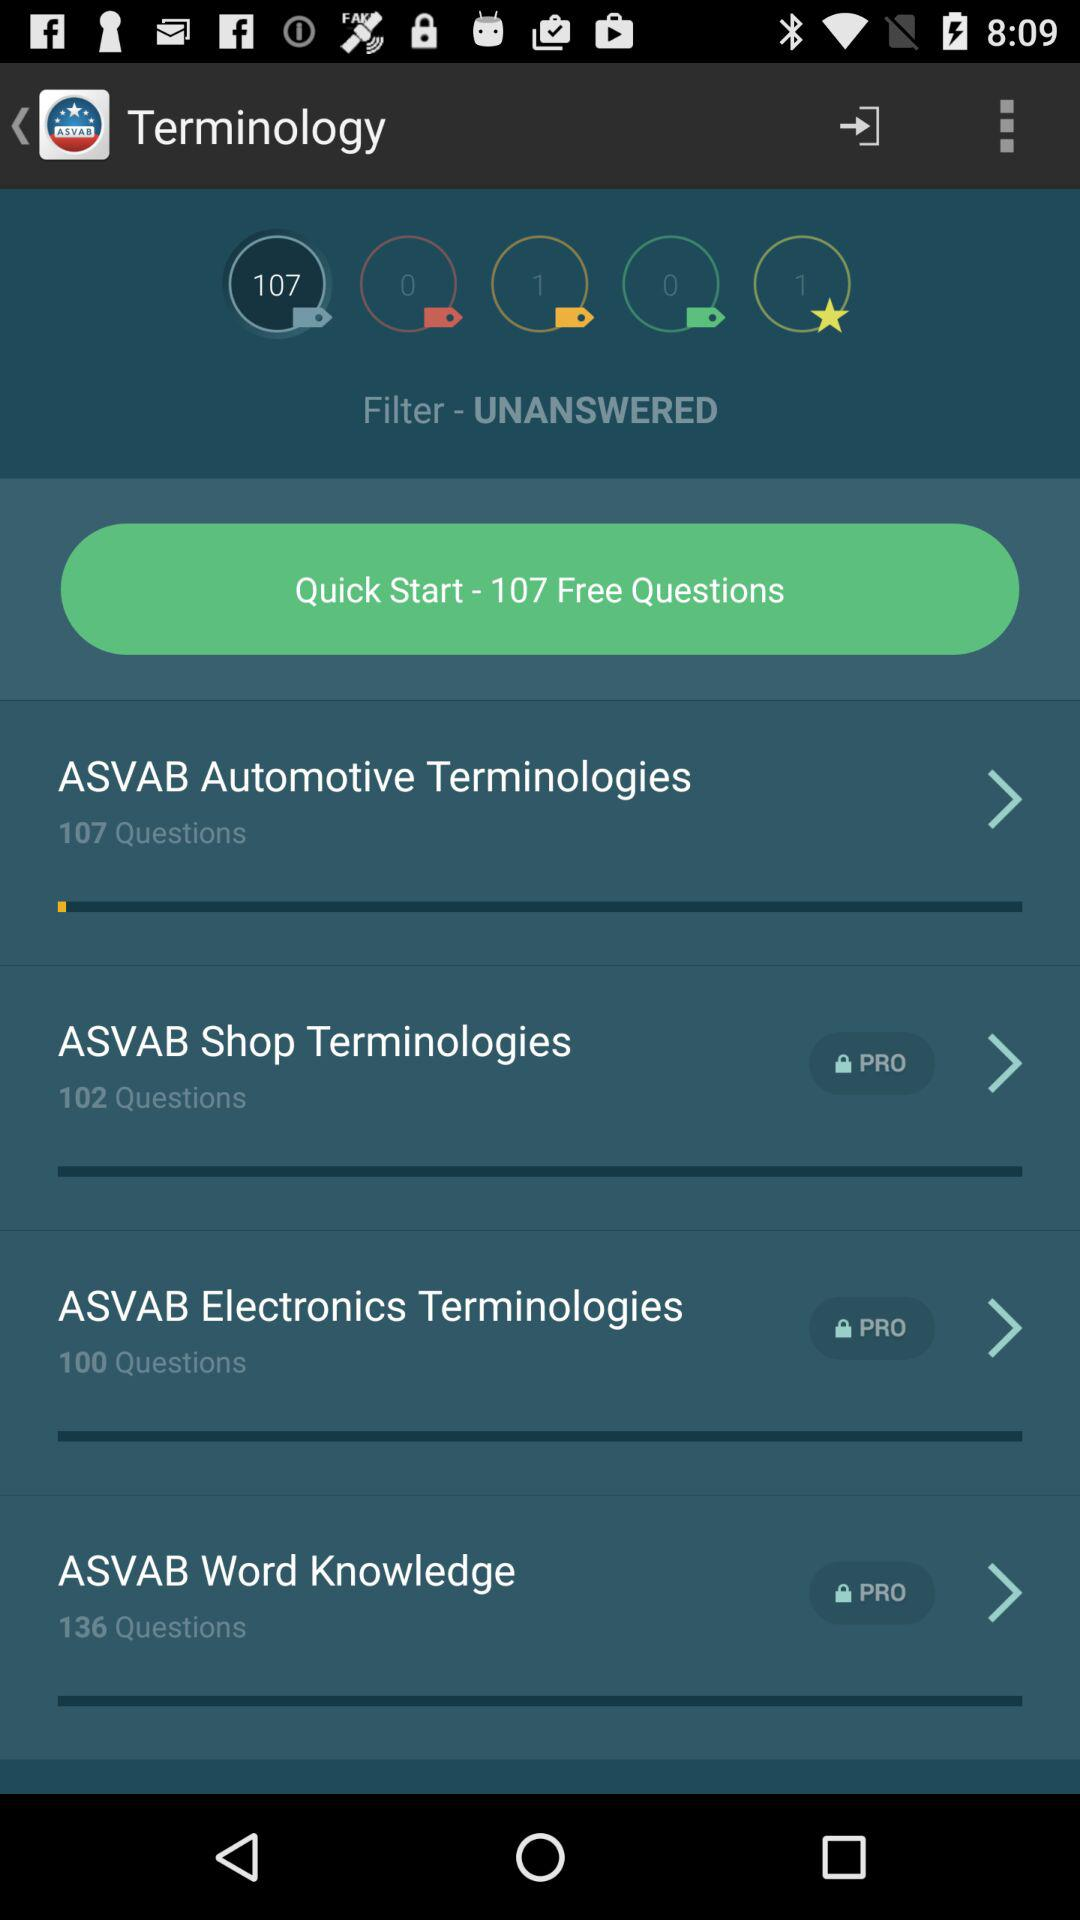How many free questions are there? There are 107 free questions. 